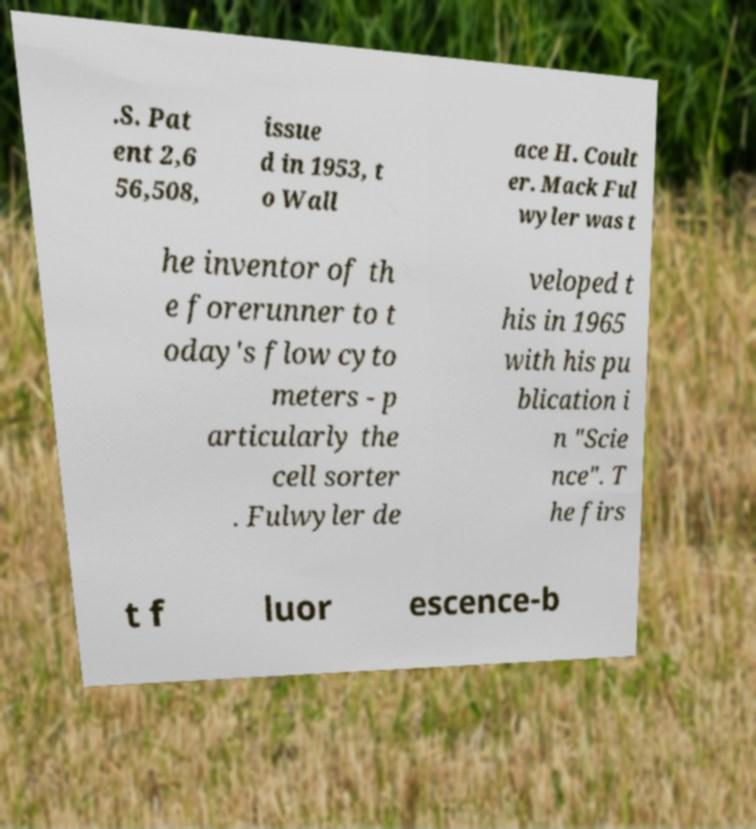For documentation purposes, I need the text within this image transcribed. Could you provide that? .S. Pat ent 2,6 56,508, issue d in 1953, t o Wall ace H. Coult er. Mack Ful wyler was t he inventor of th e forerunner to t oday's flow cyto meters - p articularly the cell sorter . Fulwyler de veloped t his in 1965 with his pu blication i n "Scie nce". T he firs t f luor escence-b 